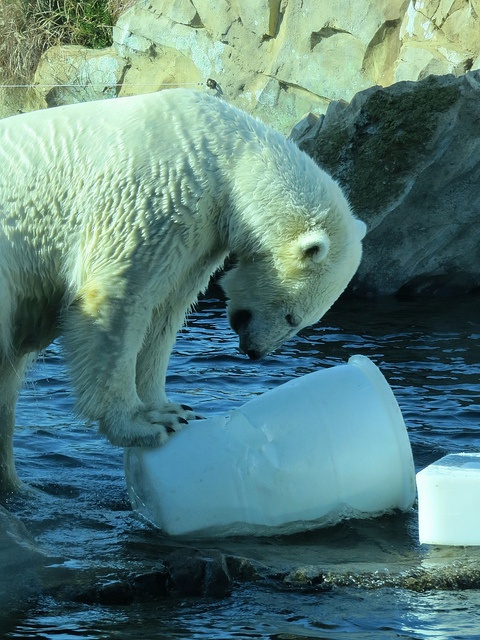Describe the objects in this image and their specific colors. I can see a bear in beige, teal, and lightgreen tones in this image. 